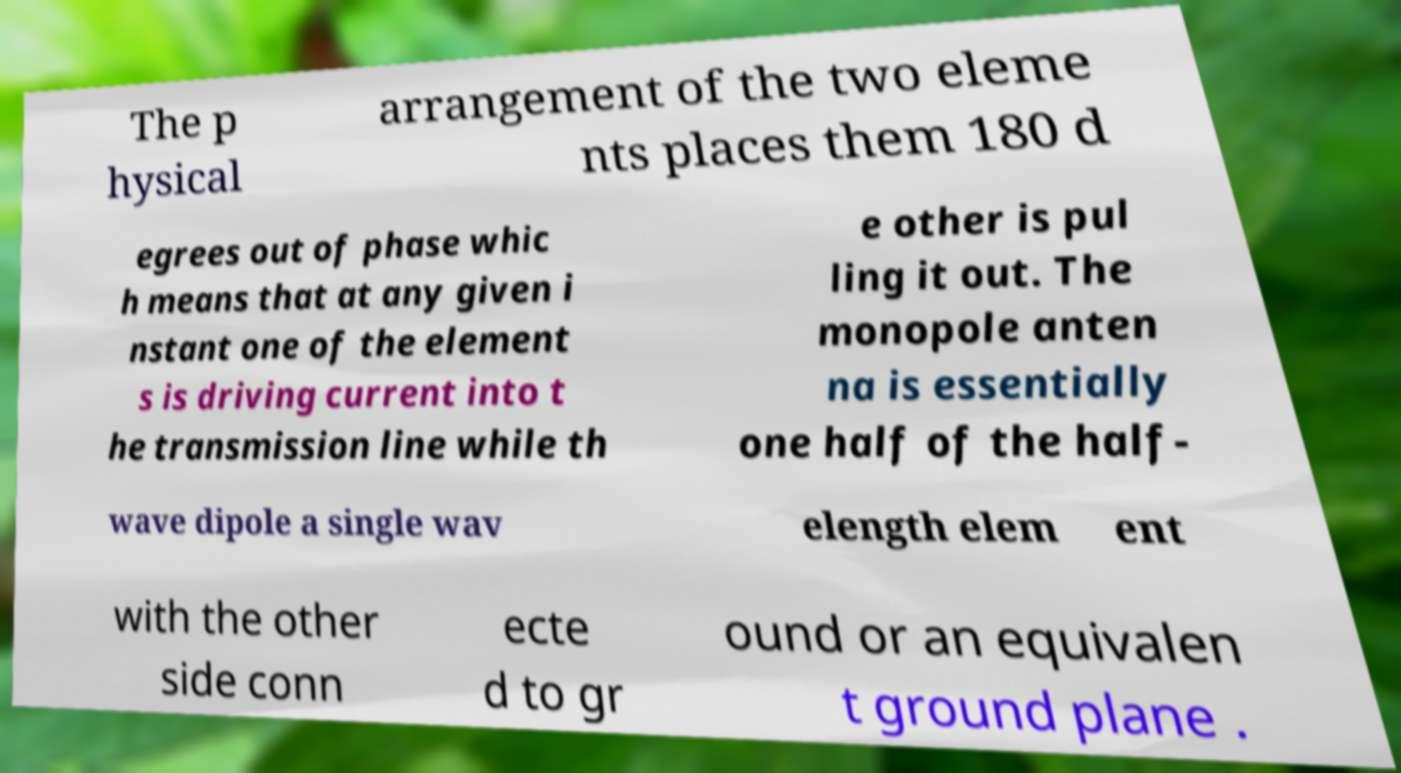Could you assist in decoding the text presented in this image and type it out clearly? The p hysical arrangement of the two eleme nts places them 180 d egrees out of phase whic h means that at any given i nstant one of the element s is driving current into t he transmission line while th e other is pul ling it out. The monopole anten na is essentially one half of the half- wave dipole a single wav elength elem ent with the other side conn ecte d to gr ound or an equivalen t ground plane . 